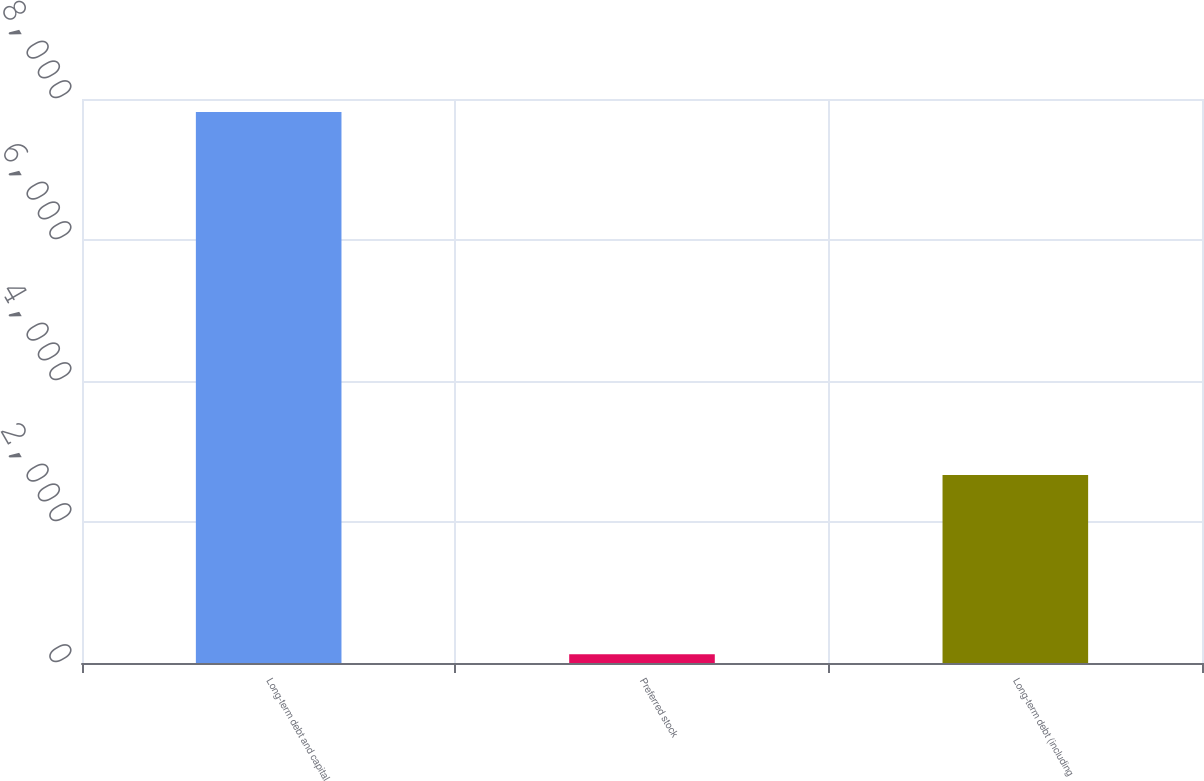Convert chart to OTSL. <chart><loc_0><loc_0><loc_500><loc_500><bar_chart><fcel>Long-term debt and capital<fcel>Preferred stock<fcel>Long-term debt (including<nl><fcel>7814<fcel>125<fcel>2665<nl></chart> 